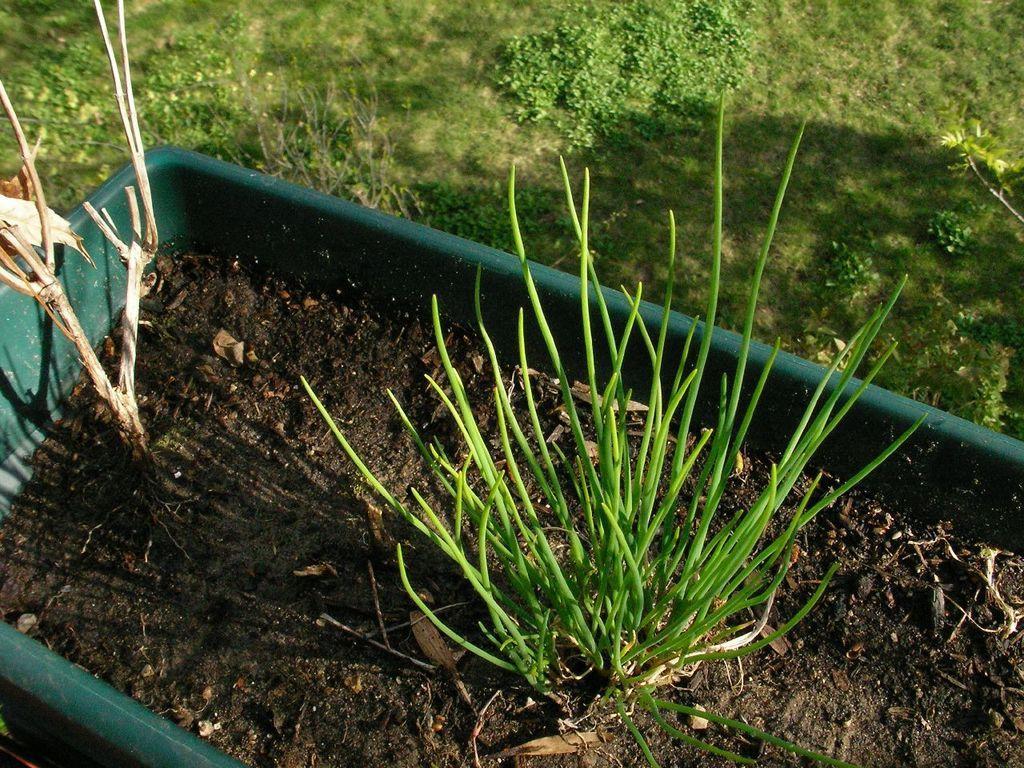How would you summarize this image in a sentence or two? There is a plant in a green tub. Behind that there is grass. 